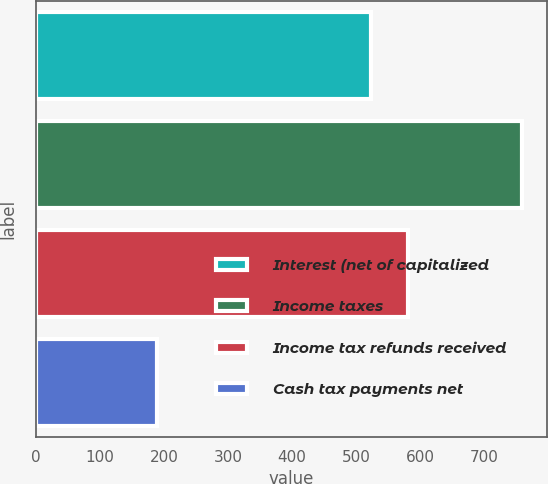Convert chart to OTSL. <chart><loc_0><loc_0><loc_500><loc_500><bar_chart><fcel>Interest (net of capitalized<fcel>Income taxes<fcel>Income tax refunds received<fcel>Cash tax payments net<nl><fcel>524<fcel>760<fcel>581.1<fcel>189<nl></chart> 